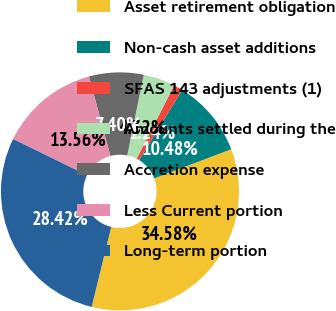Convert chart. <chart><loc_0><loc_0><loc_500><loc_500><pie_chart><fcel>Asset retirement obligation<fcel>Non-cash asset additions<fcel>SFAS 143 adjustments (1)<fcel>Amounts settled during the<fcel>Accretion expense<fcel>Less Current portion<fcel>Long-term portion<nl><fcel>34.58%<fcel>10.48%<fcel>1.24%<fcel>4.32%<fcel>7.4%<fcel>13.56%<fcel>28.42%<nl></chart> 